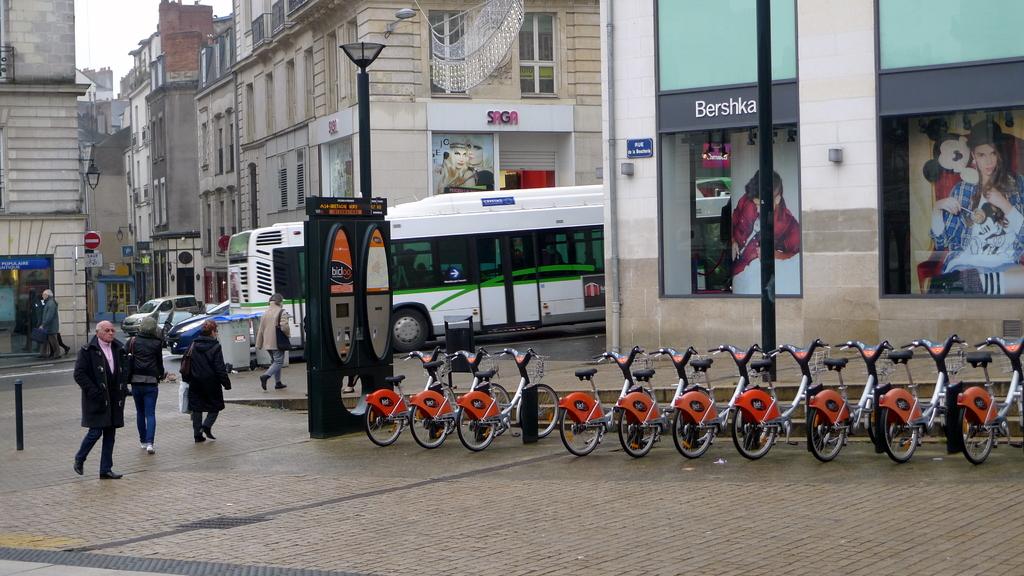Can you rent those bicycles?
Give a very brief answer. Yes. What is wrote on the first building on the right above the picture?
Keep it short and to the point. Bershka. 